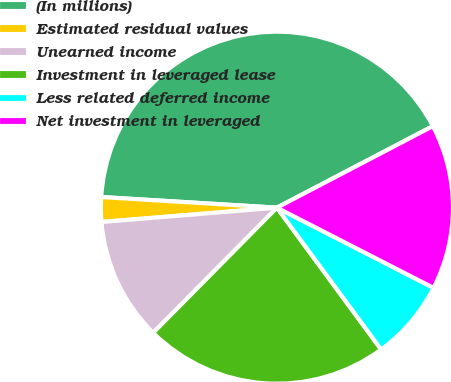Convert chart to OTSL. <chart><loc_0><loc_0><loc_500><loc_500><pie_chart><fcel>(In millions)<fcel>Estimated residual values<fcel>Unearned income<fcel>Investment in leveraged lease<fcel>Less related deferred income<fcel>Net investment in leveraged<nl><fcel>41.37%<fcel>2.26%<fcel>11.29%<fcel>22.5%<fcel>7.38%<fcel>15.2%<nl></chart> 